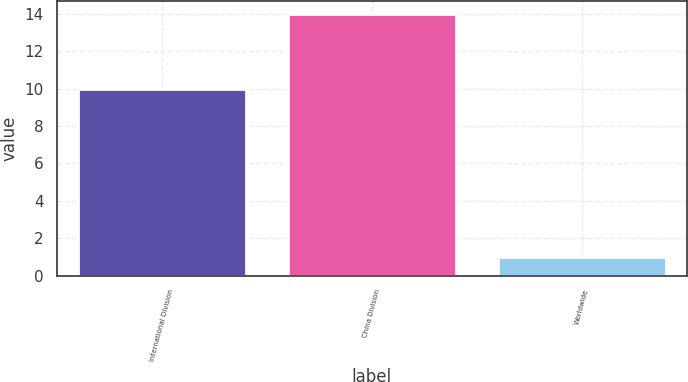Convert chart to OTSL. <chart><loc_0><loc_0><loc_500><loc_500><bar_chart><fcel>International Division<fcel>China Division<fcel>Worldwide<nl><fcel>10<fcel>14<fcel>1<nl></chart> 